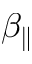<formula> <loc_0><loc_0><loc_500><loc_500>\beta _ { \| }</formula> 